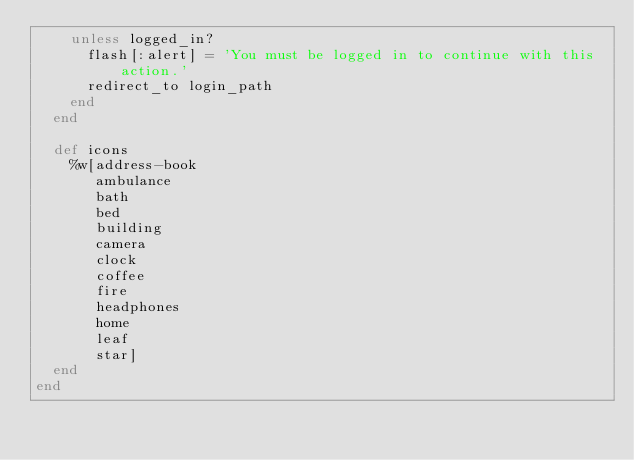<code> <loc_0><loc_0><loc_500><loc_500><_Ruby_>    unless logged_in?
      flash[:alert] = 'You must be logged in to continue with this action.'
      redirect_to login_path
    end
  end

  def icons
    %w[address-book
       ambulance
       bath
       bed
       building
       camera
       clock
       coffee
       fire
       headphones
       home
       leaf
       star]
  end
end
</code> 